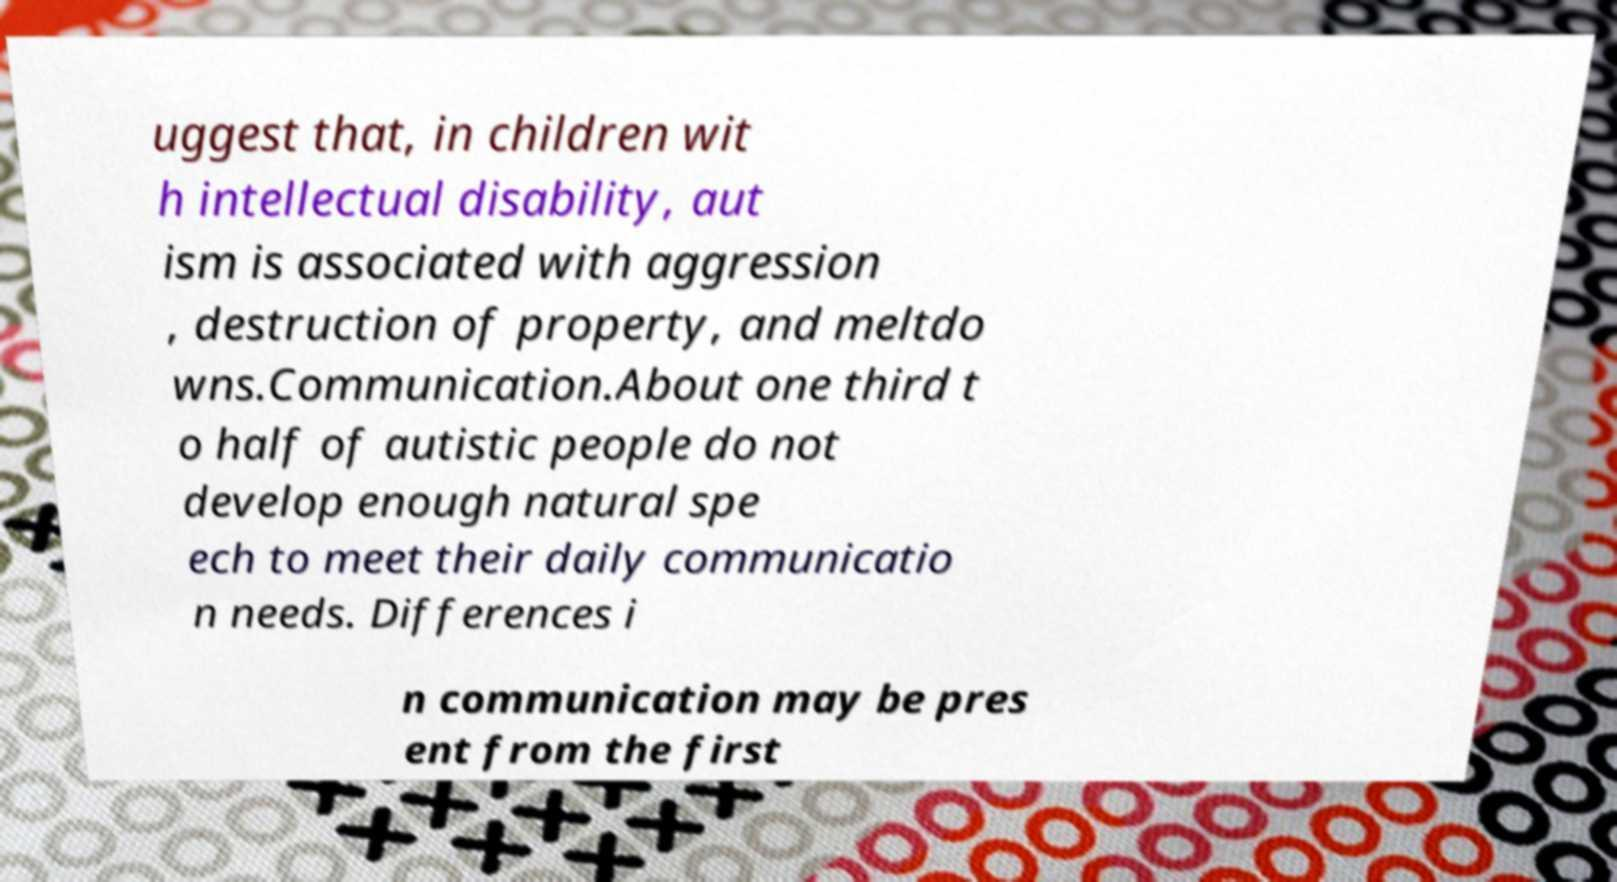Can you read and provide the text displayed in the image?This photo seems to have some interesting text. Can you extract and type it out for me? uggest that, in children wit h intellectual disability, aut ism is associated with aggression , destruction of property, and meltdo wns.Communication.About one third t o half of autistic people do not develop enough natural spe ech to meet their daily communicatio n needs. Differences i n communication may be pres ent from the first 